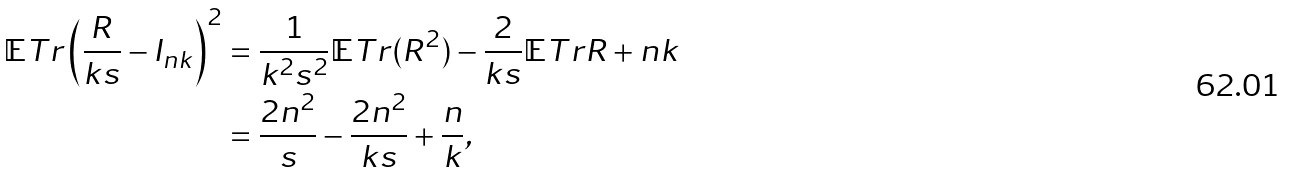<formula> <loc_0><loc_0><loc_500><loc_500>\mathbb { E } T r \left ( \frac { R } { k s } - I _ { n k } \right ) ^ { 2 } & = \frac { 1 } { k ^ { 2 } s ^ { 2 } } \mathbb { E } T r ( R ^ { 2 } ) - \frac { 2 } { k s } \mathbb { E } T r R + n k \\ & = \frac { 2 n ^ { 2 } } { s } - \frac { 2 n ^ { 2 } } { k s } + \frac { n } { k } ,</formula> 